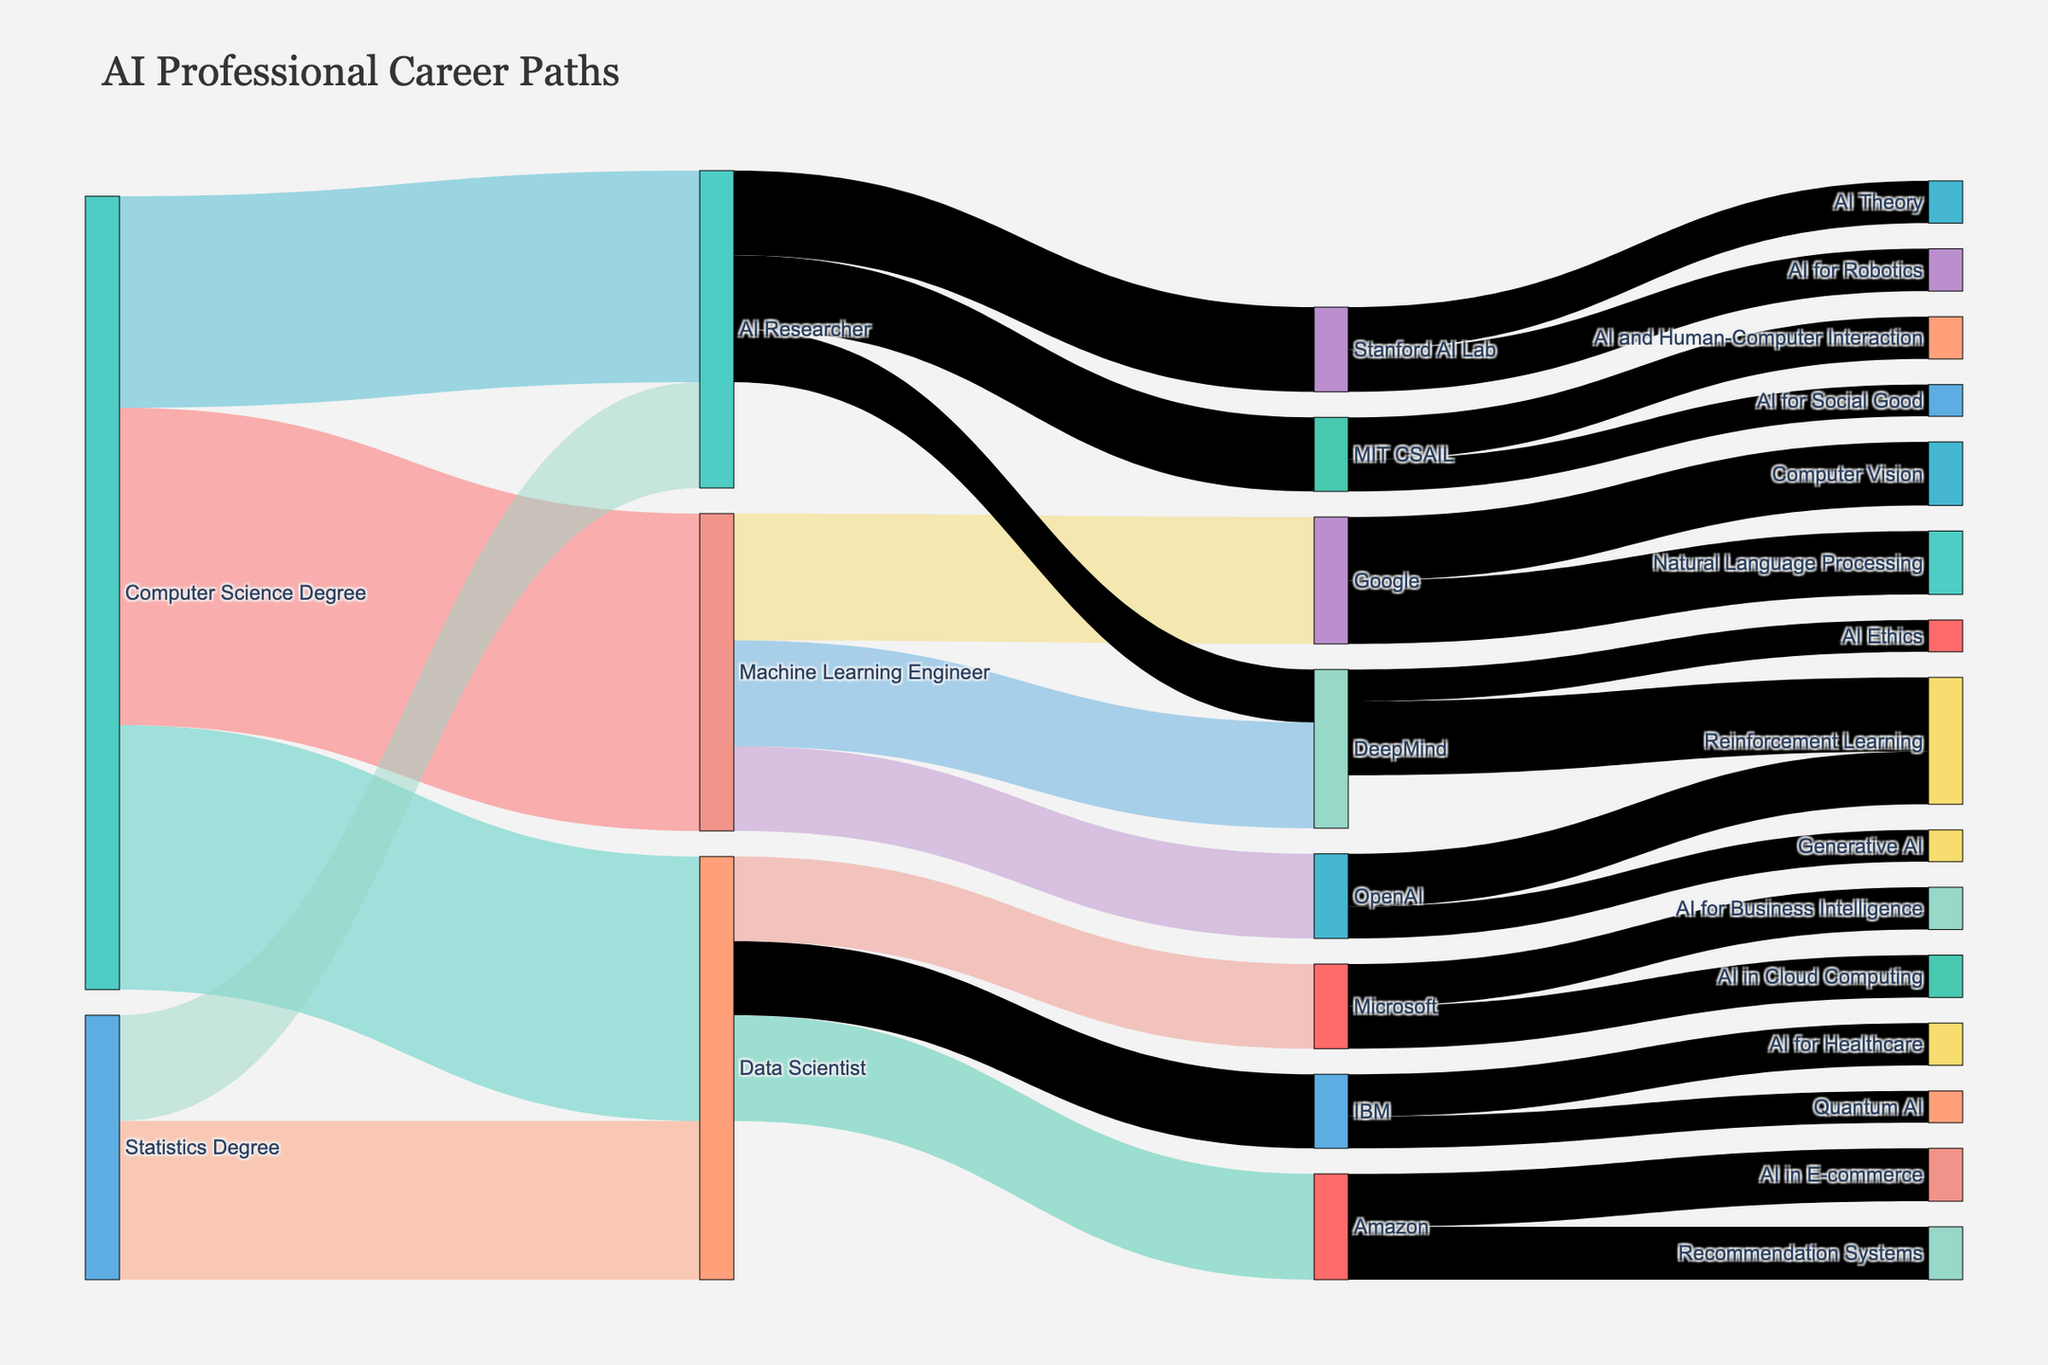Which degree produces the highest number of AI professionals? To find the degree that produces the highest number of AI professionals, sum the values connected to each degree: for Computer Science Degree, it's 30 (Machine Learning Engineer) + 25 (Data Scientist) + 20 (AI Researcher) = 75; for Statistics Degree, it's 15 (Data Scientist) + 10 (AI Researcher) = 25. The Computer Science Degree has the highest number.
Answer: Computer Science Degree Which role at DeepMind focuses on Reinforcement Learning? Look at the roles at DeepMind and check for any mentions of Reinforcement Learning. It’s shown that the role Machine Learning Engineer focuses on Reinforcement Learning.
Answer: Machine Learning Engineer How many AI professionals from Computer Science Degrees become Data Scientists? Check the flow from 'Computer Science Degree' to 'Data Scientist' in the diagram. The value next to this flow is 25.
Answer: 25 Which company employs the most Data Scientists? Compare the values for Data Scientists across different companies: Amazon (10), Microsoft (8), and IBM (7). Amazon employs the most Data Scientists.
Answer: Amazon Between Google and DeepMind, which has more professionals working in Computer Vision? Google has a flow with a value of 6 for Computer Vision, and there's no flow from DeepMind to Computer Vision. Hence, Google has more professionals in this field.
Answer: Google What is the total number of AI Researchers working in academic institutions? Count the values connected from AI Researcher to academic institutions, Stanford AI Lab (8) + MIT CSAIL (7) = 15.
Answer: 15 How many professionals are involved in Quantum AI at IBM? Check the target 'Quantum AI' from IBM. The value is 3.
Answer: 3 Which company has the most diverse set of AI specializations? Count the number of different specializations for each company: Google (2, Natural Language Processing and Computer Vision), OpenAI (2, Reinforcement Learning and Generative AI), DeepMind (2, Reinforcement Learning and AI Ethics), Amazon (2, Recommendation Systems and AI in E-commerce), Microsoft (2, AI in Cloud Computing and AI for Business Intelligence), IBM (2, AI for Healthcare and Quantum AI). They all have the same number of diverse specializations (2).
Answer: All are equal Which academic institution focuses on AI and Human-Computer Interaction? Look at the flows from academic institutions to specializations. MIT CSAIL has a flow value of 4 to AI and Human-Computer Interaction.
Answer: MIT CSAIL 